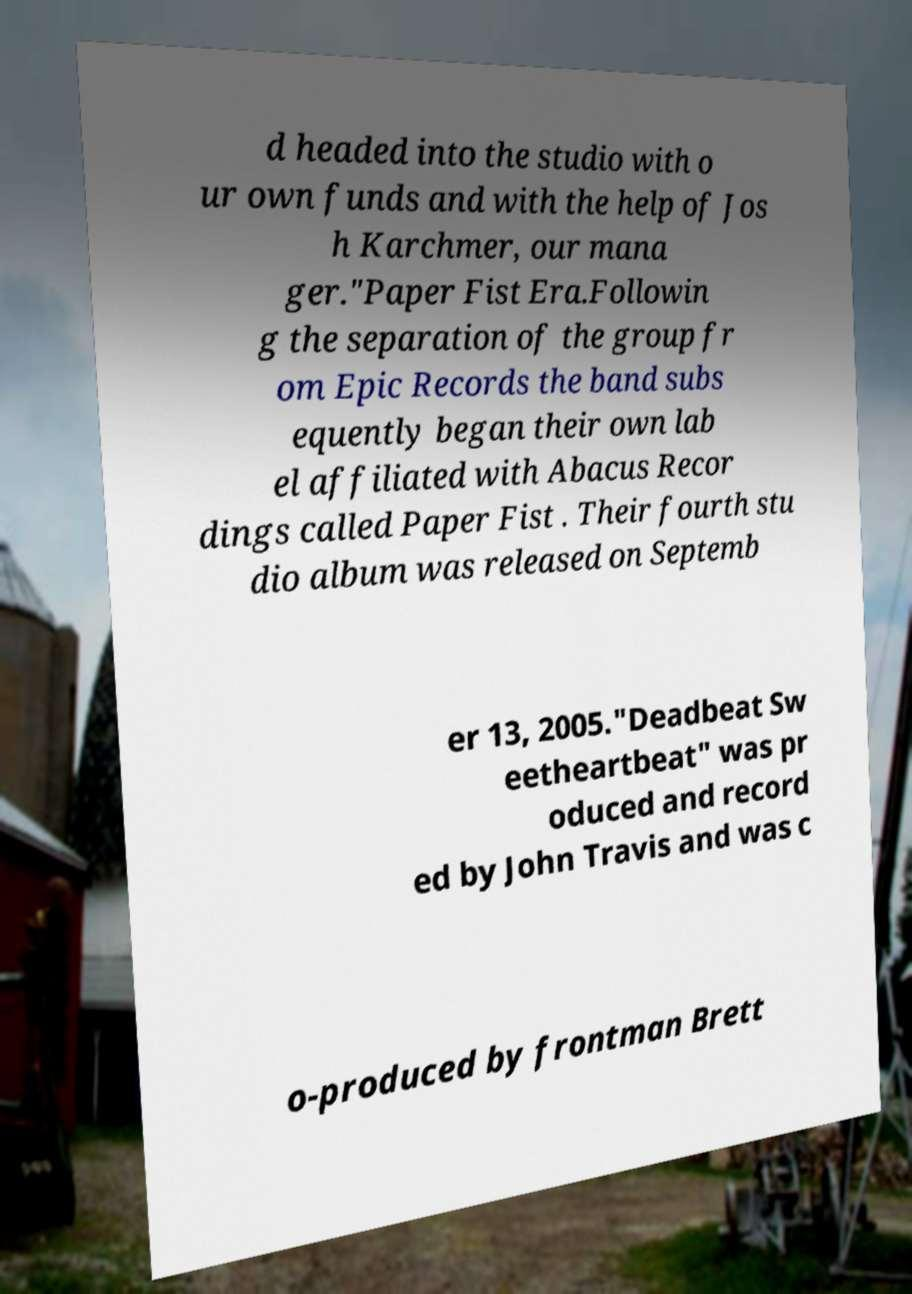Could you extract and type out the text from this image? d headed into the studio with o ur own funds and with the help of Jos h Karchmer, our mana ger."Paper Fist Era.Followin g the separation of the group fr om Epic Records the band subs equently began their own lab el affiliated with Abacus Recor dings called Paper Fist . Their fourth stu dio album was released on Septemb er 13, 2005."Deadbeat Sw eetheartbeat" was pr oduced and record ed by John Travis and was c o-produced by frontman Brett 